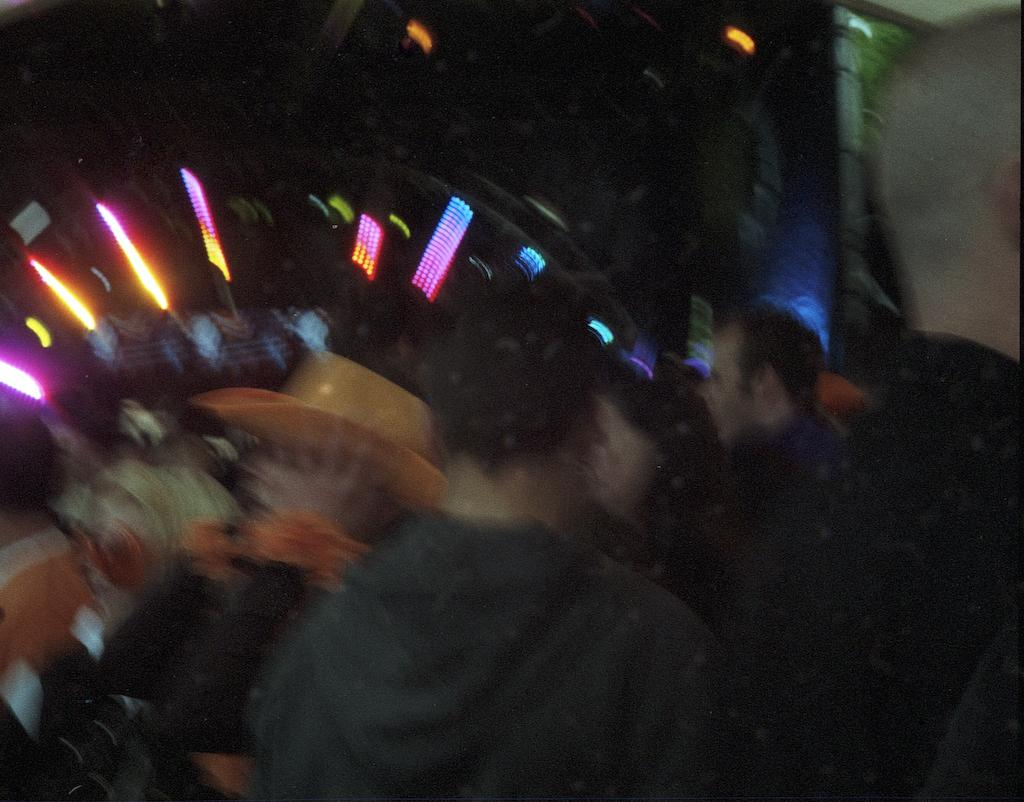How many people are in the image? There is a group of people in the image. Can you describe any specific clothing item worn by someone in the group? One person in the group is wearing a cap. What can be seen in the background of the image? There are lights visible in the background of the image. What type of winter sport is being performed by the group in the image? There is no indication of a winter sport or any sport being performed in the image. 